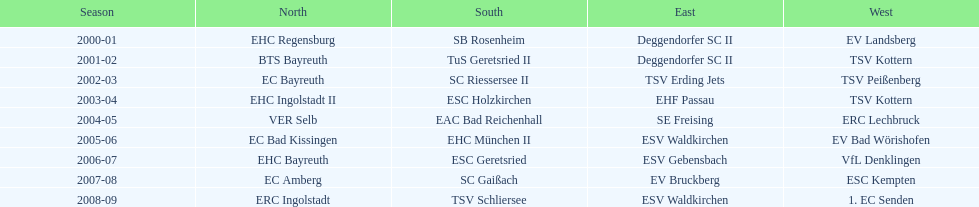Could you parse the entire table? {'header': ['Season', 'North', 'South', 'East', 'West'], 'rows': [['2000-01', 'EHC Regensburg', 'SB Rosenheim', 'Deggendorfer SC II', 'EV Landsberg'], ['2001-02', 'BTS Bayreuth', 'TuS Geretsried II', 'Deggendorfer SC II', 'TSV Kottern'], ['2002-03', 'EC Bayreuth', 'SC Riessersee II', 'TSV Erding Jets', 'TSV Peißenberg'], ['2003-04', 'EHC Ingolstadt II', 'ESC Holzkirchen', 'EHF Passau', 'TSV Kottern'], ['2004-05', 'VER Selb', 'EAC Bad Reichenhall', 'SE Freising', 'ERC Lechbruck'], ['2005-06', 'EC Bad Kissingen', 'EHC München II', 'ESV Waldkirchen', 'EV Bad Wörishofen'], ['2006-07', 'EHC Bayreuth', 'ESC Geretsried', 'ESV Gebensbach', 'VfL Denklingen'], ['2007-08', 'EC Amberg', 'SC Gaißach', 'EV Bruckberg', 'ESC Kempten'], ['2008-09', 'ERC Ingolstadt', 'TSV Schliersee', 'ESV Waldkirchen', '1. EC Senden']]} How many champions are listend in the north? 9. 